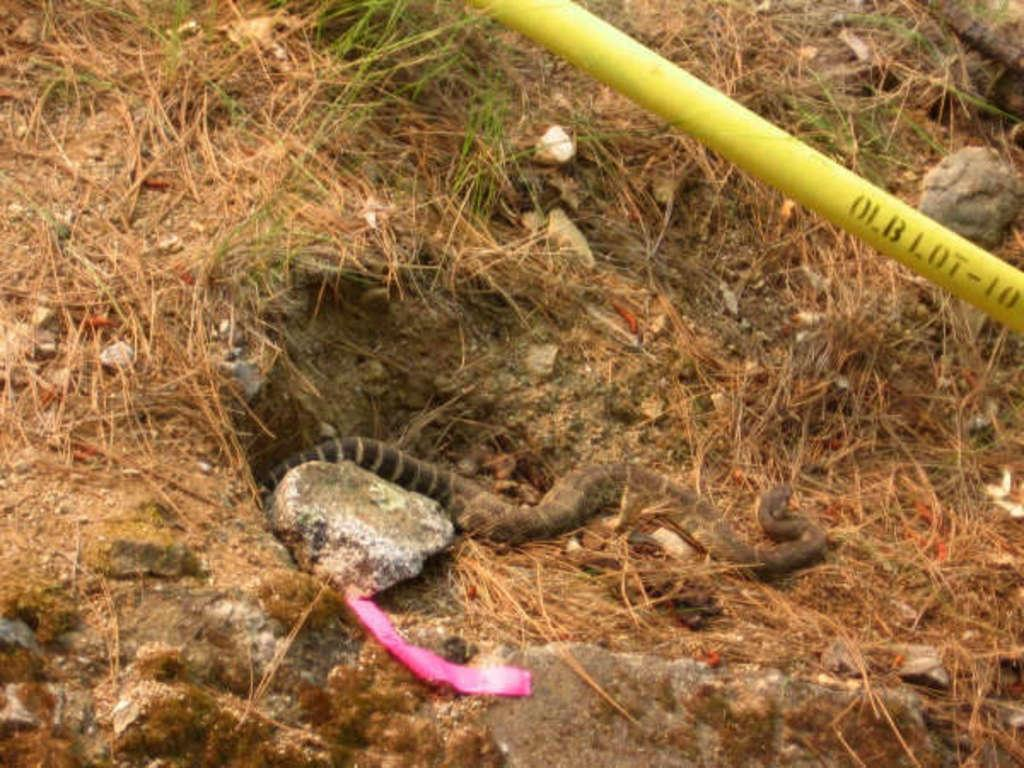What type of vegetation is present on the ground in the image? There is grass on the ground in the image. What animal can be seen on the ground in the image? There is a snake on the ground in the image. What man-made object is visible in the image? There is a yellow color metal pipe in the image. How many ladybugs can be seen crawling on the snake in the image? There are no ladybugs present in the image; it only features a snake and grass on the ground. 